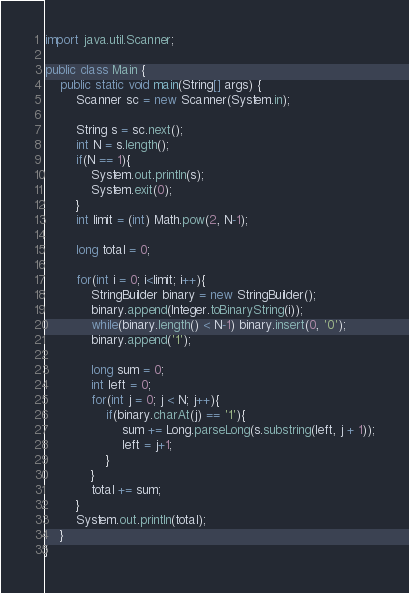Convert code to text. <code><loc_0><loc_0><loc_500><loc_500><_Java_>import java.util.Scanner;

public class Main {
	public static void main(String[] args) {
		Scanner sc = new Scanner(System.in);
		
		String s = sc.next();
		int N = s.length();
		if(N == 1){
			System.out.println(s);
			System.exit(0);
		}
		int limit = (int) Math.pow(2, N-1);
		
		long total = 0;
		
		for(int i = 0; i<limit; i++){
			StringBuilder binary = new StringBuilder();
			binary.append(Integer.toBinaryString(i));
			while(binary.length() < N-1) binary.insert(0, '0');
			binary.append('1');
			
			long sum = 0;
			int left = 0;
			for(int j = 0; j < N; j++){
				if(binary.charAt(j) == '1'){
					sum += Long.parseLong(s.substring(left, j + 1));
					left = j+1;
				}
			}
			total += sum;
		}
		System.out.println(total);
	}
}</code> 